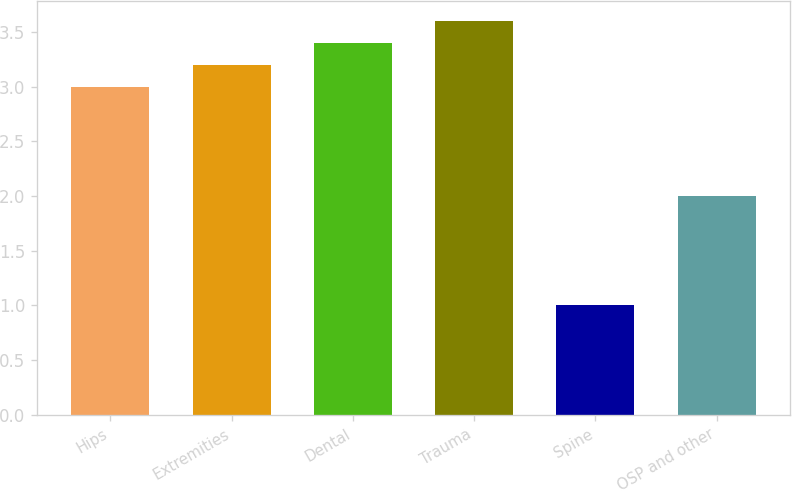<chart> <loc_0><loc_0><loc_500><loc_500><bar_chart><fcel>Hips<fcel>Extremities<fcel>Dental<fcel>Trauma<fcel>Spine<fcel>OSP and other<nl><fcel>3<fcel>3.2<fcel>3.4<fcel>3.6<fcel>1<fcel>2<nl></chart> 